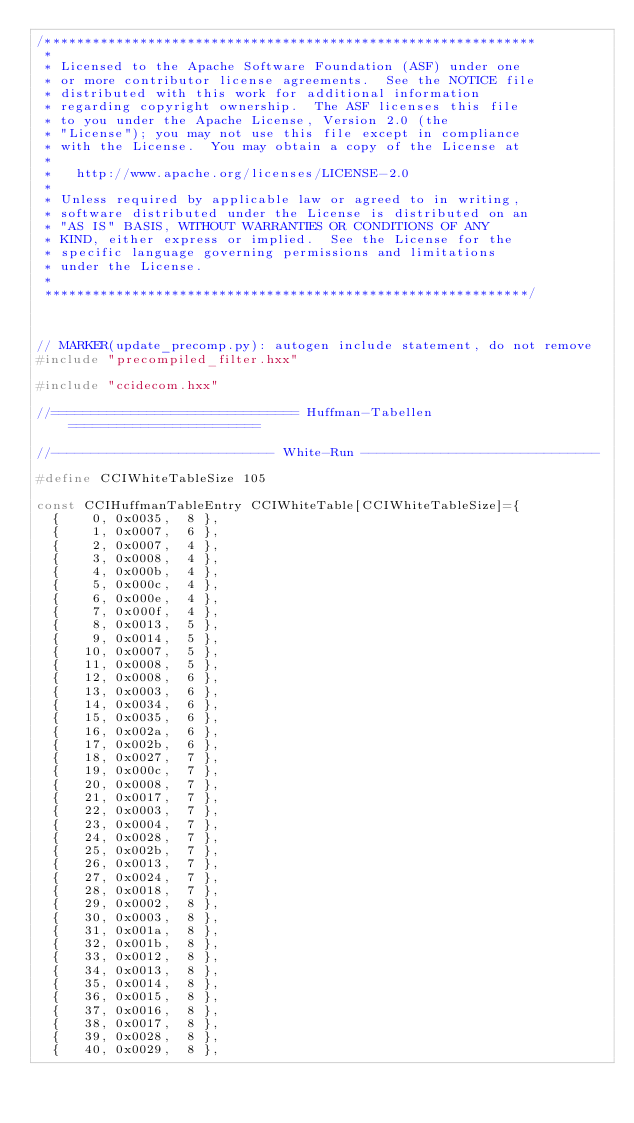<code> <loc_0><loc_0><loc_500><loc_500><_C++_>/**************************************************************
 * 
 * Licensed to the Apache Software Foundation (ASF) under one
 * or more contributor license agreements.  See the NOTICE file
 * distributed with this work for additional information
 * regarding copyright ownership.  The ASF licenses this file
 * to you under the Apache License, Version 2.0 (the
 * "License"); you may not use this file except in compliance
 * with the License.  You may obtain a copy of the License at
 * 
 *   http://www.apache.org/licenses/LICENSE-2.0
 * 
 * Unless required by applicable law or agreed to in writing,
 * software distributed under the License is distributed on an
 * "AS IS" BASIS, WITHOUT WARRANTIES OR CONDITIONS OF ANY
 * KIND, either express or implied.  See the License for the
 * specific language governing permissions and limitations
 * under the License.
 * 
 *************************************************************/



// MARKER(update_precomp.py): autogen include statement, do not remove
#include "precompiled_filter.hxx"

#include "ccidecom.hxx"

//=============================== Huffman-Tabellen ========================

//---------------------------- White-Run ------------------------------

#define CCIWhiteTableSize 105

const CCIHuffmanTableEntry CCIWhiteTable[CCIWhiteTableSize]={
	{    0, 0x0035,  8 },
	{    1, 0x0007,  6 },
	{    2, 0x0007,  4 },
	{    3, 0x0008,  4 },
	{    4, 0x000b,  4 },
	{    5, 0x000c,  4 },
	{    6, 0x000e,  4 },
	{    7, 0x000f,  4 },
	{    8, 0x0013,  5 },
	{    9, 0x0014,  5 },
	{   10, 0x0007,  5 },
	{   11, 0x0008,  5 },
	{   12, 0x0008,  6 },
	{   13, 0x0003,  6 },
	{   14, 0x0034,  6 },
	{   15, 0x0035,  6 },
	{   16, 0x002a,  6 },
	{   17, 0x002b,  6 },
	{   18, 0x0027,  7 },
	{   19, 0x000c,  7 },
	{   20, 0x0008,  7 },
	{   21, 0x0017,  7 },
	{   22, 0x0003,  7 },
	{   23, 0x0004,  7 },
	{   24, 0x0028,  7 },
	{   25, 0x002b,  7 },
	{   26, 0x0013,  7 },
	{   27, 0x0024,  7 },
	{   28, 0x0018,  7 },
	{   29, 0x0002,  8 },
	{   30, 0x0003,  8 },
	{   31, 0x001a,  8 },
	{   32, 0x001b,  8 },
	{   33, 0x0012,  8 },
	{   34, 0x0013,  8 },
	{   35, 0x0014,  8 },
	{   36, 0x0015,  8 },
	{   37, 0x0016,  8 },
	{   38, 0x0017,  8 },
	{   39, 0x0028,  8 },
	{   40, 0x0029,  8 },</code> 